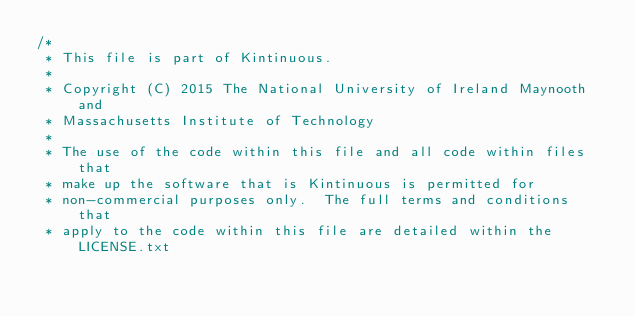<code> <loc_0><loc_0><loc_500><loc_500><_Cuda_>/*
 * This file is part of Kintinuous.
 *
 * Copyright (C) 2015 The National University of Ireland Maynooth and 
 * Massachusetts Institute of Technology
 *
 * The use of the code within this file and all code within files that 
 * make up the software that is Kintinuous is permitted for 
 * non-commercial purposes only.  The full terms and conditions that 
 * apply to the code within this file are detailed within the LICENSE.txt </code> 